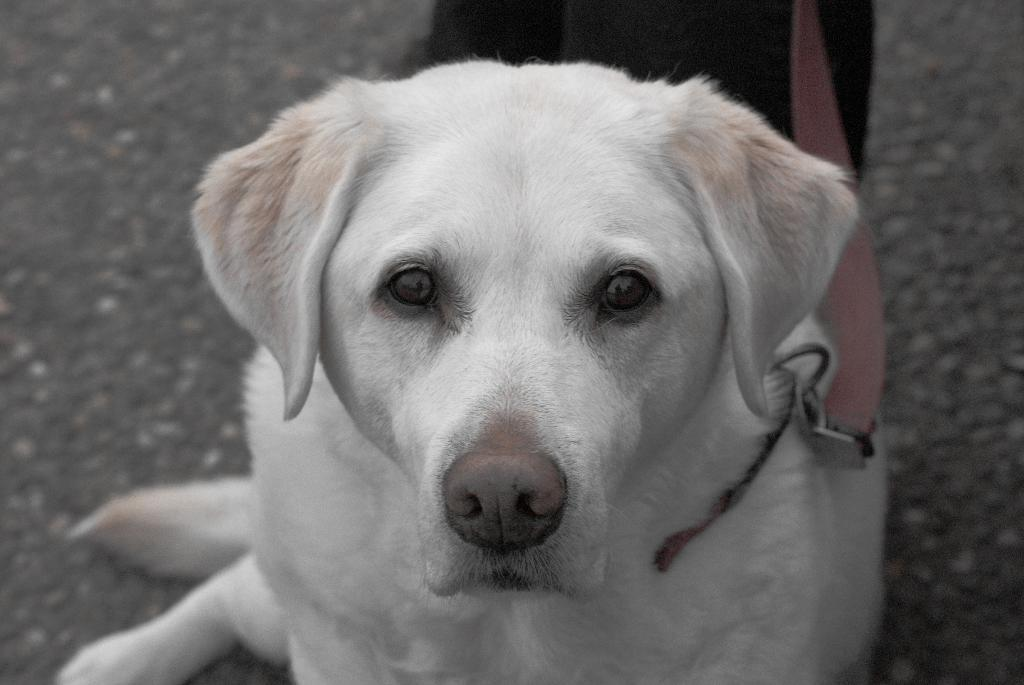What type of animal can be seen in the image? There is a dog in the image. How much of the dog is visible in the image? The dog is truncated or partially visible in the image. What is attached to the dog in the image? There is a leash in the image. Can you identify any human presence in the image? Yes, there is a person in the image. How much of the person is visible in the image? The person is truncated or partially visible in the image. What type of surface can be seen in the image? There is a road in the image. What type of grass is growing on the army's uniform in the image? There is no army or grass present in the image; it features a dog, a person, a leash, and a road. 